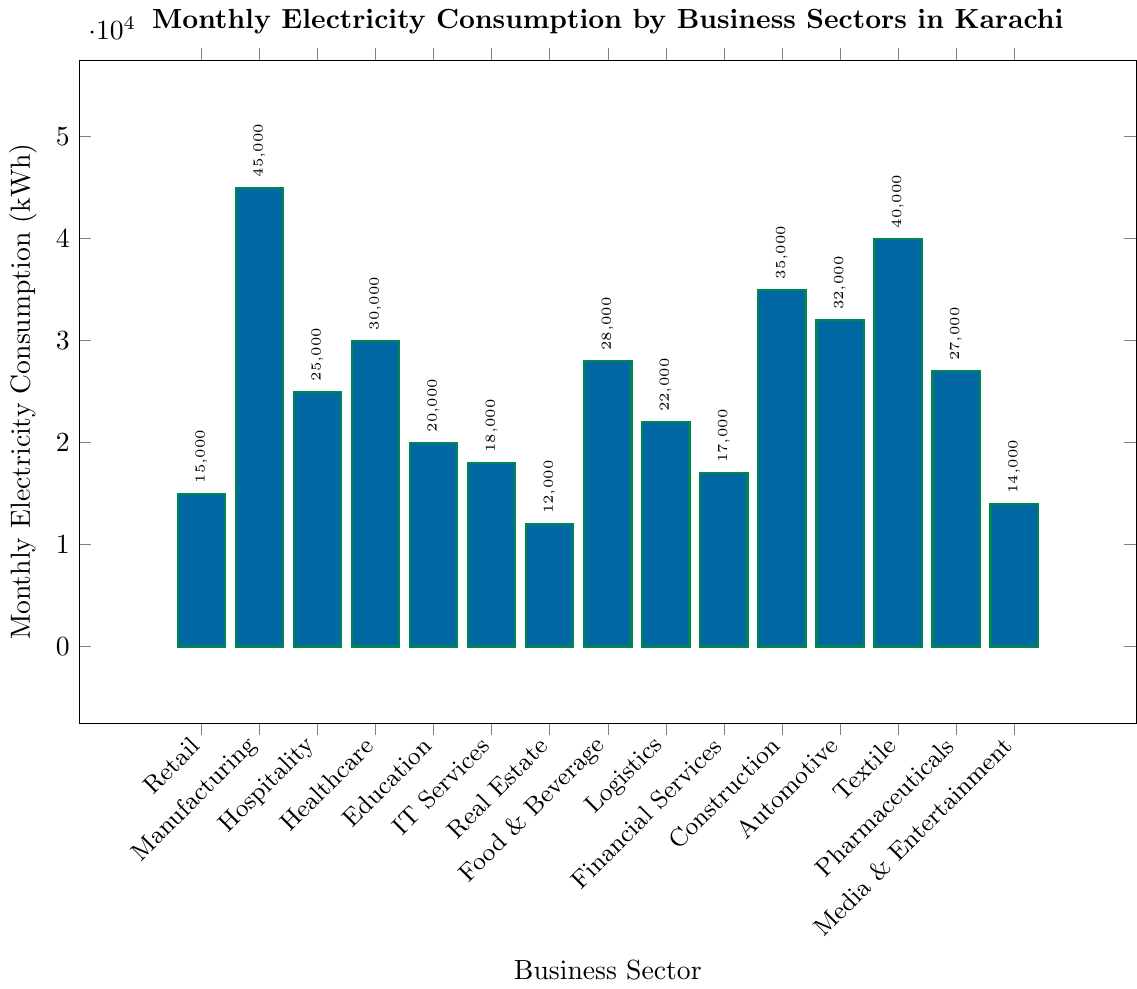What is the business sector with the highest monthly electricity consumption? The bar representing the Manufacturing sector is the tallest among all the bars in the chart, indicating that Manufacturing has the highest monthly electricity consumption.
Answer: Manufacturing Which two business sectors have the closest monthly electricity consumption values? By visually comparing the heights of the bars, we can see that the bars for IT Services and Financial Services are very close in height.
Answer: IT Services and Financial Services How much more electricity does Manufacturing consume compared to Retail? The monthly electricity consumption of Manufacturing is 45000 kWh and for Retail, it is 15000 kWh. The difference is 45000 - 15000 = 30000 kWh.
Answer: 30000 kWh Which business sector consumes the least electricity? The bar representing Real Estate is the shortest among all the bars, indicating that Real Estate has the lowest monthly electricity consumption.
Answer: Real Estate What is the total monthly electricity consumption for Healthcare, Education, and IT Services combined? The monthly consumptions are 30000 kWh for Healthcare, 20000 kWh for Education, and 18000 kWh for IT Services. The total consumption is 30000 + 20000 + 18000 = 68000 kWh.
Answer: 68000 kWh Which sectors have a monthly consumption greater than 30000 kWh? By comparing the heights of the bars to the 30000 kWh mark on the y-axis, we see that Manufacturing, Textile, Construction, Automotive, and Healthcare have consumption values greater than 30000 kWh.
Answer: Manufacturing, Textile, Construction, Automotive, Healthcare What is the difference in monthly electricity consumption between the Healthcare and Pharmaceuticals sectors? The monthly consumption for Healthcare is 30000 kWh and for Pharmaceuticals, it is 27000 kWh. The difference is 30000 - 27000 = 3000 kWh.
Answer: 3000 kWh What is the average monthly consumption for the Textile and Food & Beverage sectors? The monthly consumption for Textile is 40000 kWh and for Food & Beverage, it is 28000 kWh. The average is (40000 + 28000) / 2 = 34000 kWh.
Answer: 34000 kWh Which three sectors consume the highest electricity? By comparing the heights of all bars, Manufacturing, Textile, and Construction are the three sectors with the highest electricity consumption.
Answer: Manufacturing, Textile, Construction Is the monthly electricity consumption of the Automotive sector more than double that of the Retail sector? The monthly consumption for Automotive is 32000 kWh and for Retail, it is 15000 kWh. Double the Retail consumption is 15000 * 2 = 30000 kWh. Since 32000 > 30000, the Automotive sector's consumption is indeed more than double that of the Retail sector.
Answer: Yes 